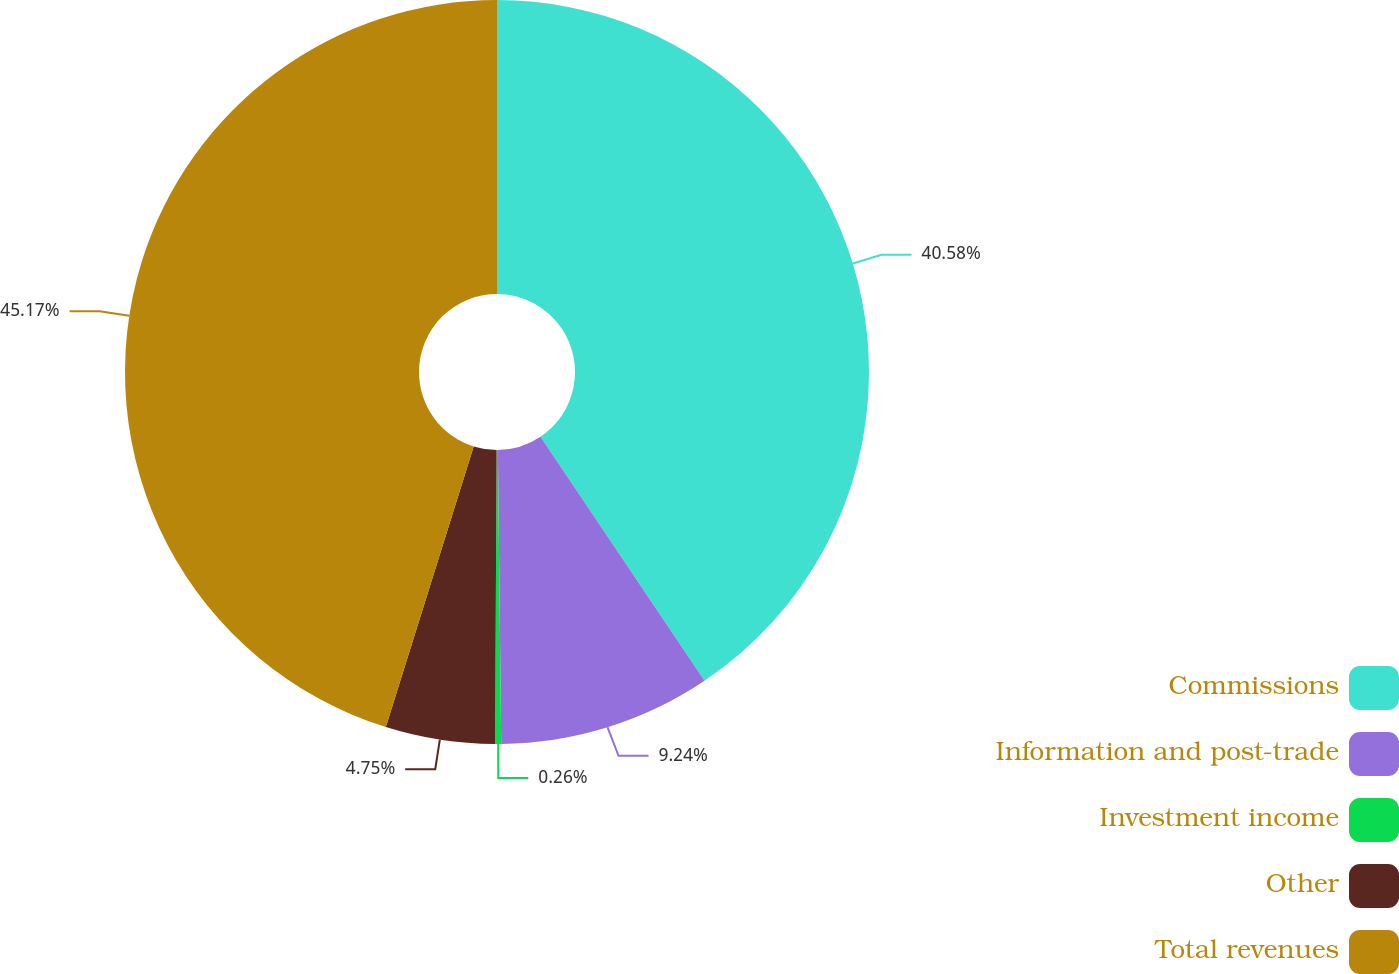<chart> <loc_0><loc_0><loc_500><loc_500><pie_chart><fcel>Commissions<fcel>Information and post-trade<fcel>Investment income<fcel>Other<fcel>Total revenues<nl><fcel>40.58%<fcel>9.24%<fcel>0.26%<fcel>4.75%<fcel>45.17%<nl></chart> 